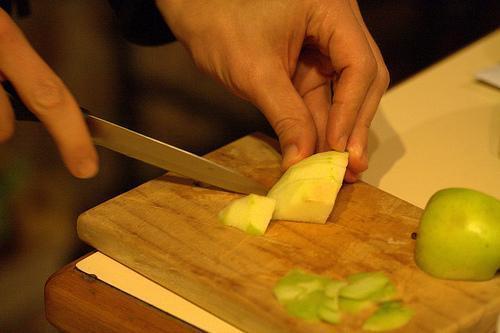How many apples are there?
Give a very brief answer. 1. 